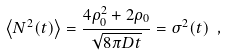Convert formula to latex. <formula><loc_0><loc_0><loc_500><loc_500>\left < N ^ { 2 } ( t ) \right > = \frac { 4 \rho _ { 0 } ^ { 2 } + 2 \rho _ { 0 } } { \sqrt { 8 \pi D t } } = \sigma ^ { 2 } ( t ) \ ,</formula> 